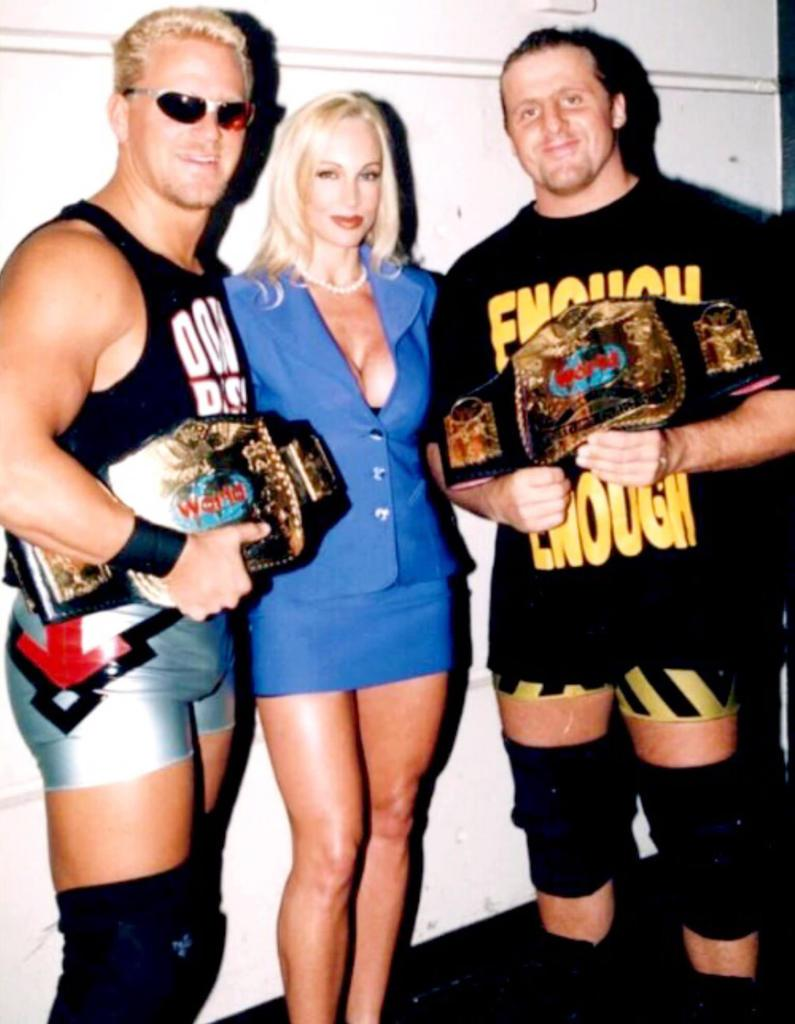<image>
Relay a brief, clear account of the picture shown. A woman poses with two wrestlers, one of whom is wearing an ENOUGH IS ENOUGH t-shirt. 